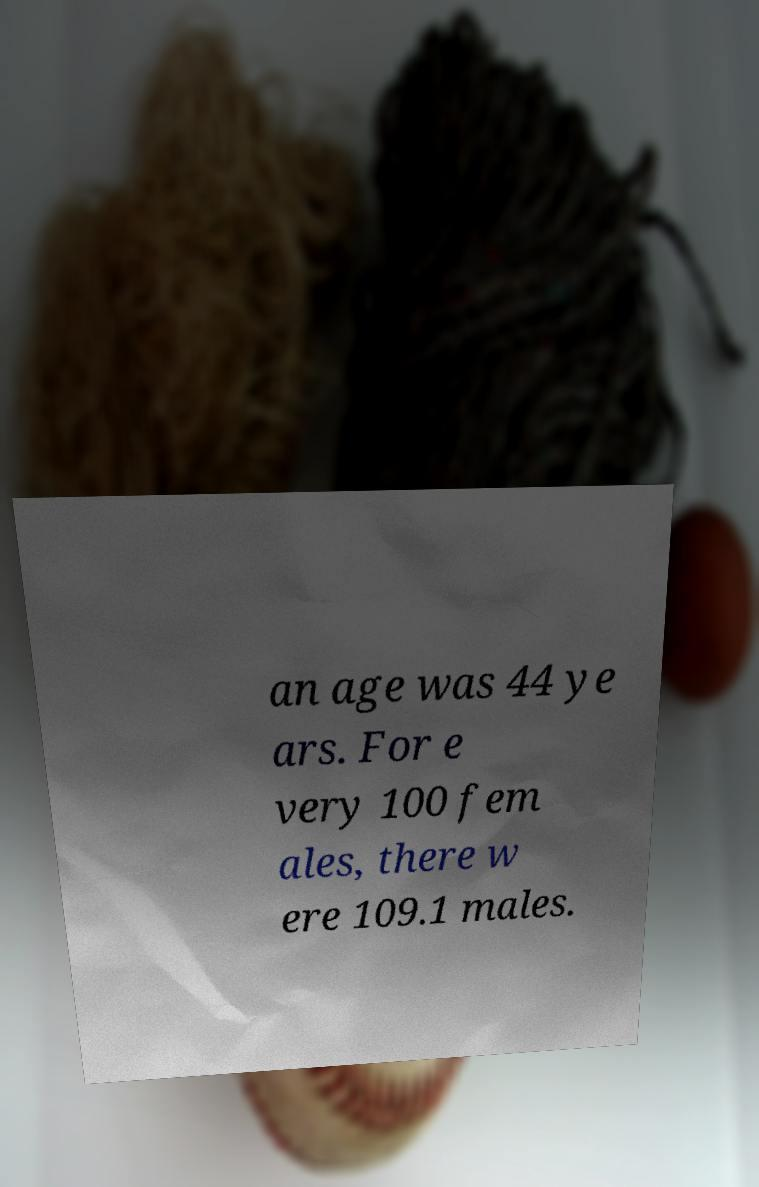Please read and relay the text visible in this image. What does it say? an age was 44 ye ars. For e very 100 fem ales, there w ere 109.1 males. 